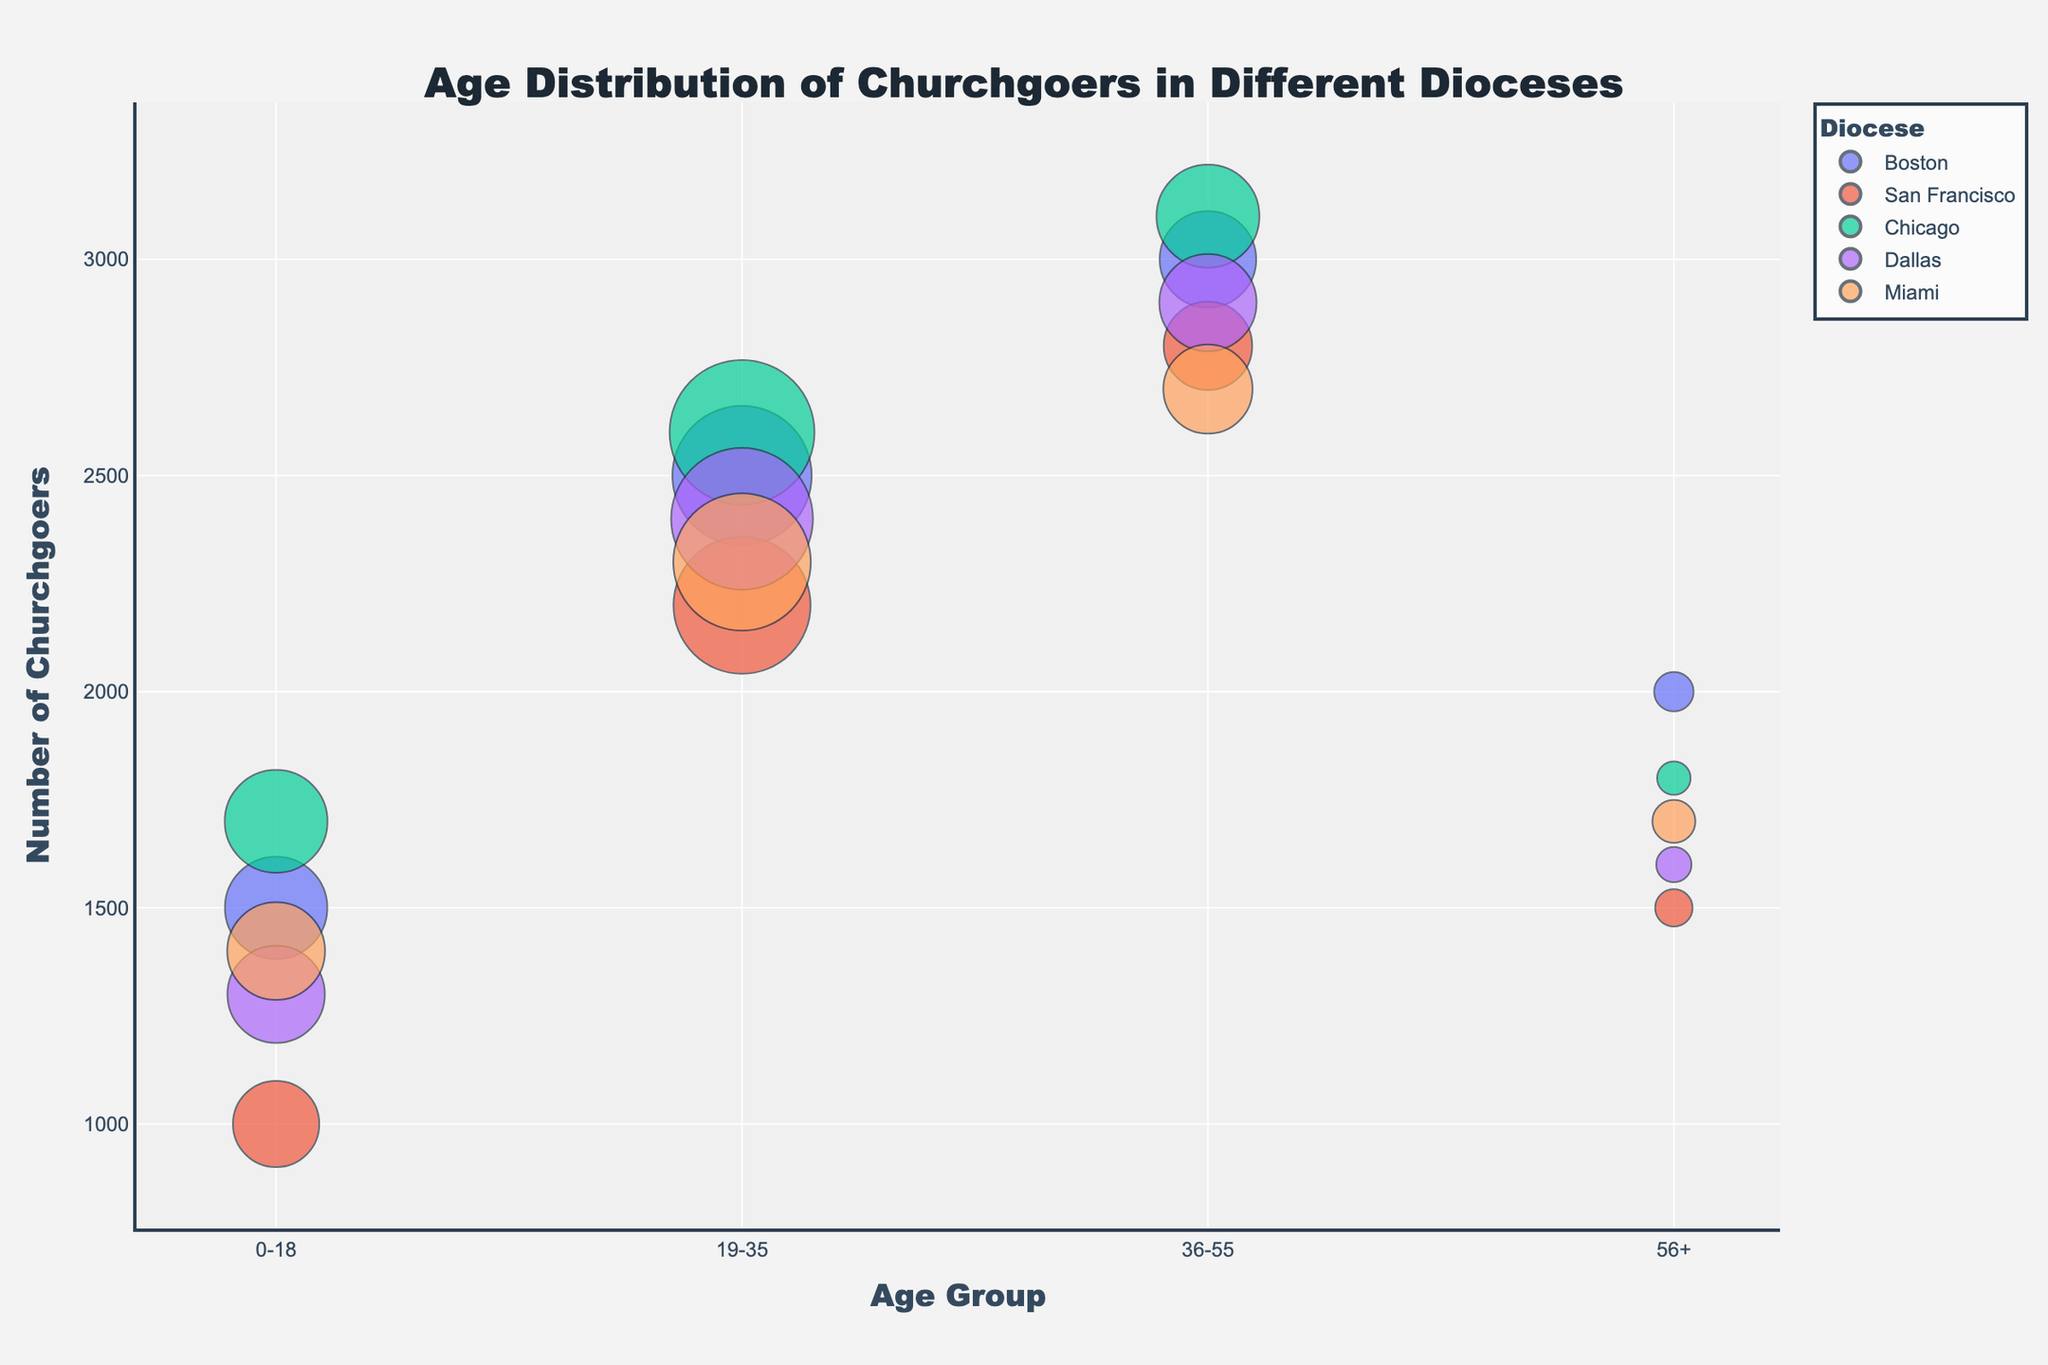What is the title of the bubble chart? The title of the bubble chart is displayed prominently at the top of the figure. It reads "Age Distribution of Churchgoers in Different Dioceses".
Answer: Age Distribution of Churchgoers in Different Dioceses Which diocese has the highest youth engagement percentage for the 19-35 age group? To find the diocese with the highest youth engagement percentage for the 19-35 age group, look at the bubbles corresponding to this age group and compare the youth engagement percentages in the hover data.
Answer: San Francisco How many churchgoers are there in the 0-18 age group in Chicago? Locate the bubble representing the 0-18 age group for Chicago, and read off the y-axis value for that bubble, which shows the number of churchgoers.
Answer: 1700 Which age group in Boston has the lowest youth engagement percentage? Review the youth engagement percentages for all age groups in Boston by looking at the hover data for each bubble and find the lowest percentage.
Answer: 56+ What is the total number of churchgoers in the 19-35 age group across all dioceses? Sum the number of churchgoers for the 19-35 age group by adding the y-values for all corresponding bubbles. Calculation: 2500 (Boston) + 2200 (San Francisco) + 2600 (Chicago) + 2400 (Dallas) + 2300 (Miami) = 12000.
Answer: 12000 Which age group shows the highest youth engagement percentage in Miami? Compare the youth engagement percentages in Miami across all age groups by looking at the hover data. The highest percentage indicates the desired age group.
Answer: 19-35 Is the number of churchgoers in the 36-55 age group greater in Chicago or Dallas? Compare the y-values for the 36-55 age group bubbles in Chicago and Dallas. Chicago has 3100 churchgoers and Dallas has 2900.
Answer: Chicago What is the average youth engagement percentage for the 0-18 age group across all dioceses? Add the youth engagement percentages for the 0-18 age group in each diocese and divide by the number of dioceses. Calculation: (45 + 48 + 40 + 47 + 44) / 5 = 44.8%
Answer: 44.8% Which diocese has the smallest bubble size for the 56+ age group? Find the smallest bubble size for the 56+ age group by checking the hover data for each bubble size in this age group.
Answer: Chicago What is the overall trend in youth engagement as age increases in San Francisco? Look at the youth engagement percentages for each age group in San Francisco and observe how they change as the age group increases.
Answer: Decreasing 